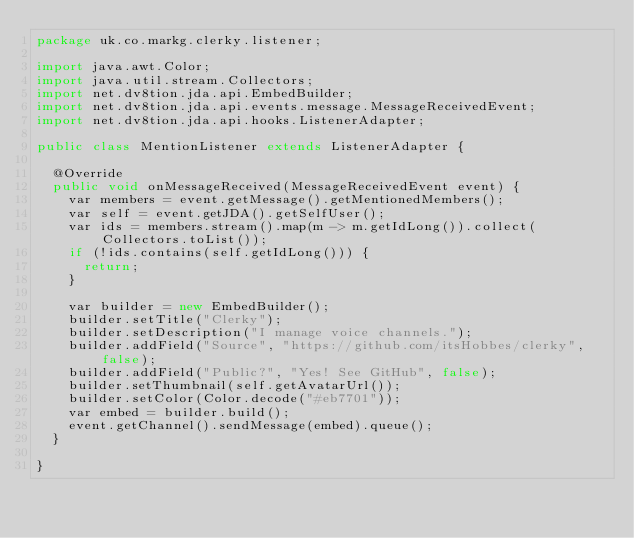<code> <loc_0><loc_0><loc_500><loc_500><_Java_>package uk.co.markg.clerky.listener;

import java.awt.Color;
import java.util.stream.Collectors;
import net.dv8tion.jda.api.EmbedBuilder;
import net.dv8tion.jda.api.events.message.MessageReceivedEvent;
import net.dv8tion.jda.api.hooks.ListenerAdapter;

public class MentionListener extends ListenerAdapter {

  @Override
  public void onMessageReceived(MessageReceivedEvent event) {
    var members = event.getMessage().getMentionedMembers();
    var self = event.getJDA().getSelfUser();
    var ids = members.stream().map(m -> m.getIdLong()).collect(Collectors.toList());
    if (!ids.contains(self.getIdLong())) {
      return;
    }

    var builder = new EmbedBuilder();
    builder.setTitle("Clerky");
    builder.setDescription("I manage voice channels.");
    builder.addField("Source", "https://github.com/itsHobbes/clerky", false);
    builder.addField("Public?", "Yes! See GitHub", false);
    builder.setThumbnail(self.getAvatarUrl());
    builder.setColor(Color.decode("#eb7701"));
    var embed = builder.build();
    event.getChannel().sendMessage(embed).queue();
  }

}
</code> 